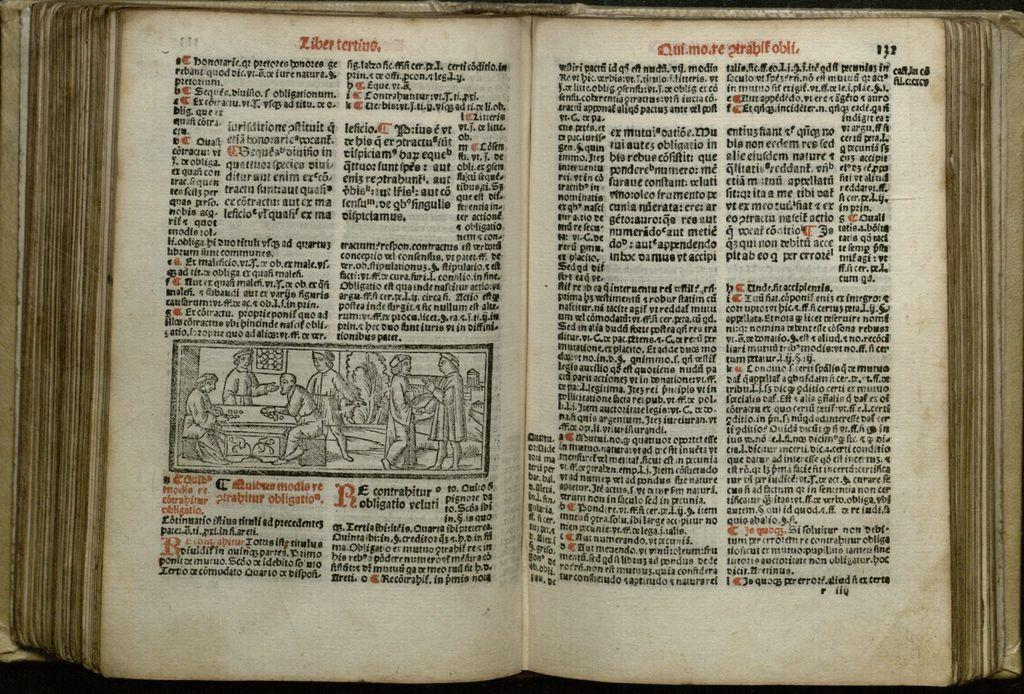<image>
Write a terse but informative summary of the picture. An old book written by Ziber Tertino is laying open to a page with a crude illustration and written in a foreign tongue. 